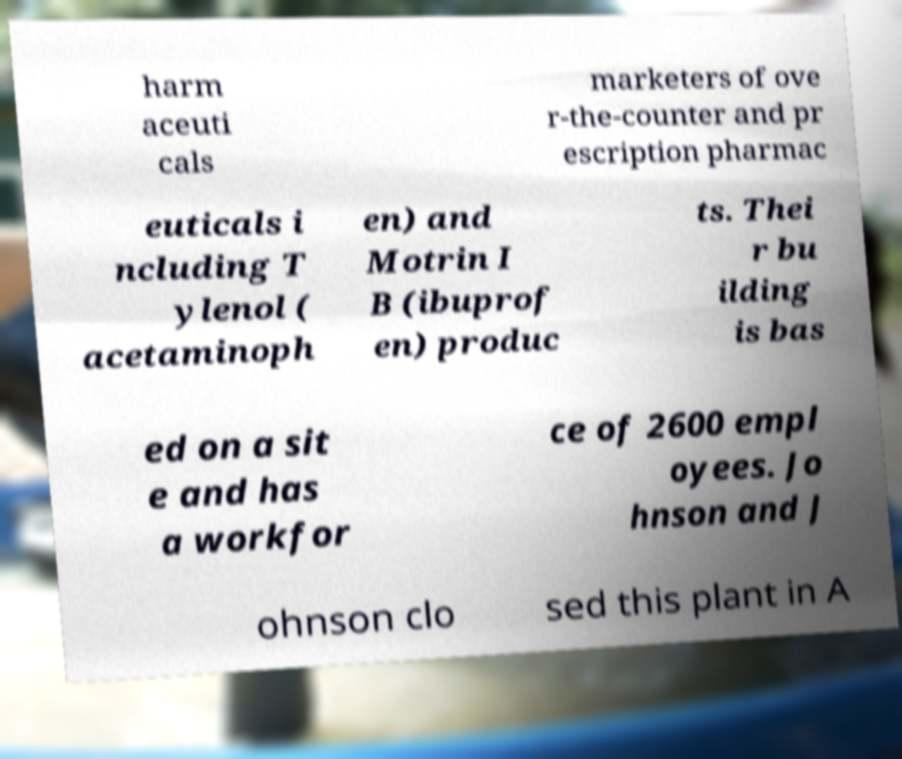Could you extract and type out the text from this image? harm aceuti cals marketers of ove r-the-counter and pr escription pharmac euticals i ncluding T ylenol ( acetaminoph en) and Motrin I B (ibuprof en) produc ts. Thei r bu ilding is bas ed on a sit e and has a workfor ce of 2600 empl oyees. Jo hnson and J ohnson clo sed this plant in A 